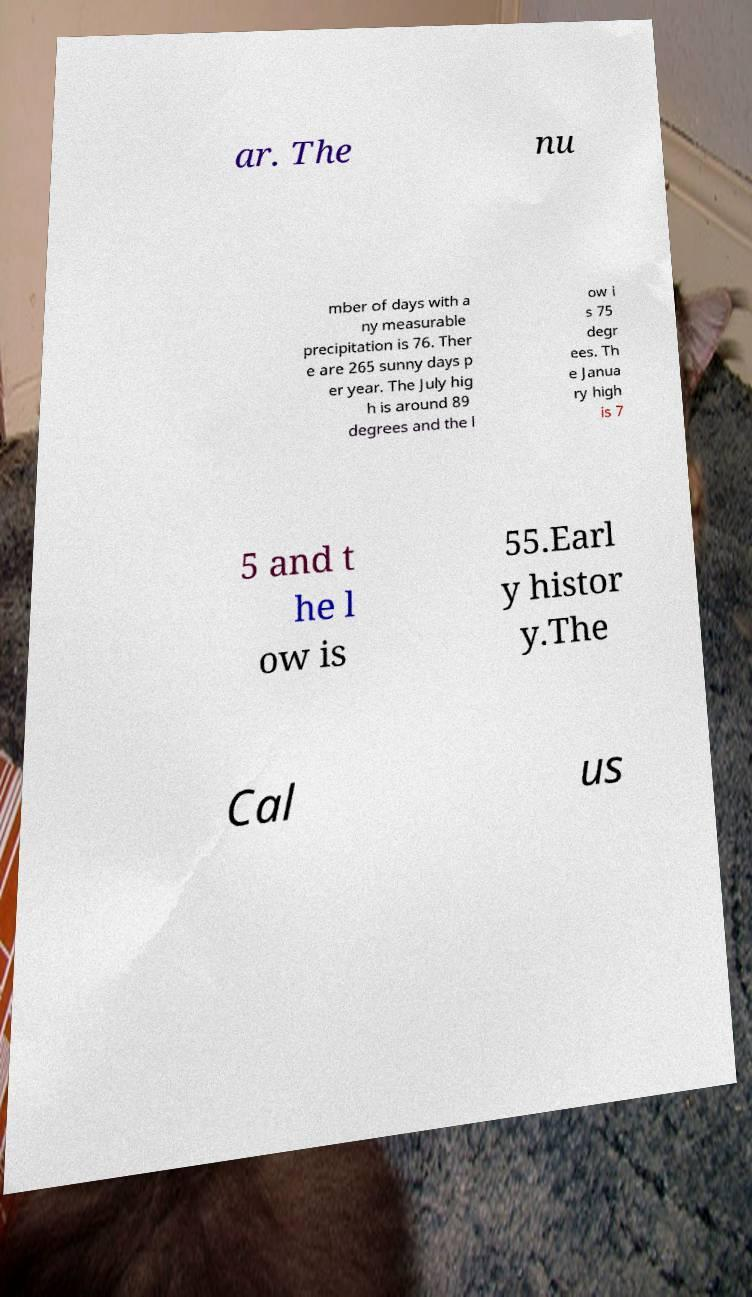I need the written content from this picture converted into text. Can you do that? ar. The nu mber of days with a ny measurable precipitation is 76. Ther e are 265 sunny days p er year. The July hig h is around 89 degrees and the l ow i s 75 degr ees. Th e Janua ry high is 7 5 and t he l ow is 55.Earl y histor y.The Cal us 